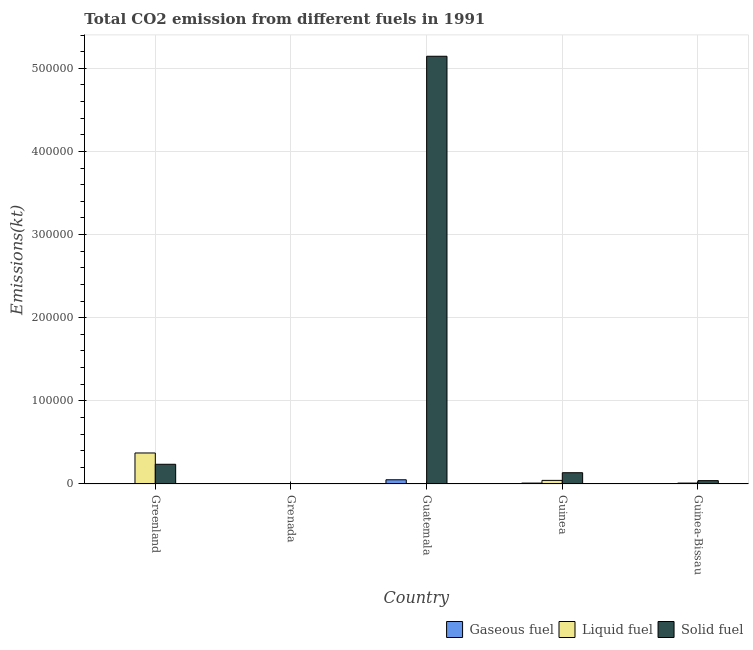How many different coloured bars are there?
Provide a short and direct response. 3. How many bars are there on the 2nd tick from the right?
Provide a succinct answer. 3. What is the label of the 3rd group of bars from the left?
Offer a terse response. Guatemala. In how many cases, is the number of bars for a given country not equal to the number of legend labels?
Offer a very short reply. 0. What is the amount of co2 emissions from gaseous fuel in Guinea?
Offer a terse response. 1074.43. Across all countries, what is the maximum amount of co2 emissions from gaseous fuel?
Offer a terse response. 5053.13. Across all countries, what is the minimum amount of co2 emissions from solid fuel?
Keep it short and to the point. 245.69. In which country was the amount of co2 emissions from liquid fuel maximum?
Offer a terse response. Greenland. In which country was the amount of co2 emissions from gaseous fuel minimum?
Make the answer very short. Grenada. What is the total amount of co2 emissions from solid fuel in the graph?
Give a very brief answer. 5.56e+05. What is the difference between the amount of co2 emissions from gaseous fuel in Greenland and that in Grenada?
Your answer should be very brief. 436.37. What is the difference between the amount of co2 emissions from gaseous fuel in Guinea-Bissau and the amount of co2 emissions from liquid fuel in Guinea?
Make the answer very short. -4059.37. What is the average amount of co2 emissions from gaseous fuel per country?
Make the answer very short. 1409.59. What is the difference between the amount of co2 emissions from liquid fuel and amount of co2 emissions from solid fuel in Guinea?
Your answer should be very brief. -9215.17. In how many countries, is the amount of co2 emissions from liquid fuel greater than 520000 kt?
Offer a terse response. 0. What is the ratio of the amount of co2 emissions from gaseous fuel in Grenada to that in Guatemala?
Make the answer very short. 0.02. Is the difference between the amount of co2 emissions from liquid fuel in Grenada and Guinea-Bissau greater than the difference between the amount of co2 emissions from solid fuel in Grenada and Guinea-Bissau?
Your answer should be compact. Yes. What is the difference between the highest and the second highest amount of co2 emissions from gaseous fuel?
Your answer should be very brief. 3978.7. What is the difference between the highest and the lowest amount of co2 emissions from solid fuel?
Provide a succinct answer. 5.14e+05. In how many countries, is the amount of co2 emissions from gaseous fuel greater than the average amount of co2 emissions from gaseous fuel taken over all countries?
Give a very brief answer. 1. Is the sum of the amount of co2 emissions from liquid fuel in Grenada and Guinea-Bissau greater than the maximum amount of co2 emissions from gaseous fuel across all countries?
Provide a succinct answer. No. What does the 2nd bar from the left in Greenland represents?
Provide a short and direct response. Liquid fuel. What does the 3rd bar from the right in Greenland represents?
Offer a very short reply. Gaseous fuel. How many countries are there in the graph?
Keep it short and to the point. 5. Are the values on the major ticks of Y-axis written in scientific E-notation?
Ensure brevity in your answer.  No. Does the graph contain any zero values?
Provide a short and direct response. No. Does the graph contain grids?
Keep it short and to the point. Yes. What is the title of the graph?
Give a very brief answer. Total CO2 emission from different fuels in 1991. Does "Ores and metals" appear as one of the legend labels in the graph?
Your answer should be compact. No. What is the label or title of the X-axis?
Provide a succinct answer. Country. What is the label or title of the Y-axis?
Make the answer very short. Emissions(kt). What is the Emissions(kt) of Gaseous fuel in Greenland?
Your answer should be very brief. 550.05. What is the Emissions(kt) in Liquid fuel in Greenland?
Provide a succinct answer. 3.73e+04. What is the Emissions(kt) in Solid fuel in Greenland?
Your response must be concise. 2.37e+04. What is the Emissions(kt) of Gaseous fuel in Grenada?
Ensure brevity in your answer.  113.68. What is the Emissions(kt) in Liquid fuel in Grenada?
Ensure brevity in your answer.  550.05. What is the Emissions(kt) of Solid fuel in Grenada?
Give a very brief answer. 245.69. What is the Emissions(kt) of Gaseous fuel in Guatemala?
Make the answer very short. 5053.13. What is the Emissions(kt) in Liquid fuel in Guatemala?
Provide a short and direct response. 113.68. What is the Emissions(kt) of Solid fuel in Guatemala?
Provide a short and direct response. 5.14e+05. What is the Emissions(kt) in Gaseous fuel in Guinea?
Keep it short and to the point. 1074.43. What is the Emissions(kt) of Liquid fuel in Guinea?
Offer a very short reply. 4316.06. What is the Emissions(kt) in Solid fuel in Guinea?
Make the answer very short. 1.35e+04. What is the Emissions(kt) in Gaseous fuel in Guinea-Bissau?
Your answer should be very brief. 256.69. What is the Emissions(kt) in Liquid fuel in Guinea-Bissau?
Your response must be concise. 1074.43. What is the Emissions(kt) of Solid fuel in Guinea-Bissau?
Offer a very short reply. 4015.36. Across all countries, what is the maximum Emissions(kt) in Gaseous fuel?
Your response must be concise. 5053.13. Across all countries, what is the maximum Emissions(kt) in Liquid fuel?
Your answer should be very brief. 3.73e+04. Across all countries, what is the maximum Emissions(kt) in Solid fuel?
Keep it short and to the point. 5.14e+05. Across all countries, what is the minimum Emissions(kt) of Gaseous fuel?
Ensure brevity in your answer.  113.68. Across all countries, what is the minimum Emissions(kt) of Liquid fuel?
Your response must be concise. 113.68. Across all countries, what is the minimum Emissions(kt) in Solid fuel?
Your answer should be compact. 245.69. What is the total Emissions(kt) of Gaseous fuel in the graph?
Offer a very short reply. 7047.97. What is the total Emissions(kt) in Liquid fuel in the graph?
Provide a short and direct response. 4.33e+04. What is the total Emissions(kt) in Solid fuel in the graph?
Offer a very short reply. 5.56e+05. What is the difference between the Emissions(kt) in Gaseous fuel in Greenland and that in Grenada?
Your answer should be very brief. 436.37. What is the difference between the Emissions(kt) in Liquid fuel in Greenland and that in Grenada?
Offer a terse response. 3.67e+04. What is the difference between the Emissions(kt) of Solid fuel in Greenland and that in Grenada?
Provide a succinct answer. 2.35e+04. What is the difference between the Emissions(kt) of Gaseous fuel in Greenland and that in Guatemala?
Make the answer very short. -4503.08. What is the difference between the Emissions(kt) in Liquid fuel in Greenland and that in Guatemala?
Keep it short and to the point. 3.72e+04. What is the difference between the Emissions(kt) in Solid fuel in Greenland and that in Guatemala?
Your answer should be compact. -4.91e+05. What is the difference between the Emissions(kt) of Gaseous fuel in Greenland and that in Guinea?
Make the answer very short. -524.38. What is the difference between the Emissions(kt) in Liquid fuel in Greenland and that in Guinea?
Offer a very short reply. 3.30e+04. What is the difference between the Emissions(kt) in Solid fuel in Greenland and that in Guinea?
Your response must be concise. 1.02e+04. What is the difference between the Emissions(kt) of Gaseous fuel in Greenland and that in Guinea-Bissau?
Provide a short and direct response. 293.36. What is the difference between the Emissions(kt) of Liquid fuel in Greenland and that in Guinea-Bissau?
Give a very brief answer. 3.62e+04. What is the difference between the Emissions(kt) in Solid fuel in Greenland and that in Guinea-Bissau?
Your response must be concise. 1.97e+04. What is the difference between the Emissions(kt) in Gaseous fuel in Grenada and that in Guatemala?
Provide a short and direct response. -4939.45. What is the difference between the Emissions(kt) of Liquid fuel in Grenada and that in Guatemala?
Offer a very short reply. 436.37. What is the difference between the Emissions(kt) of Solid fuel in Grenada and that in Guatemala?
Offer a terse response. -5.14e+05. What is the difference between the Emissions(kt) in Gaseous fuel in Grenada and that in Guinea?
Offer a very short reply. -960.75. What is the difference between the Emissions(kt) in Liquid fuel in Grenada and that in Guinea?
Make the answer very short. -3766.01. What is the difference between the Emissions(kt) of Solid fuel in Grenada and that in Guinea?
Provide a succinct answer. -1.33e+04. What is the difference between the Emissions(kt) in Gaseous fuel in Grenada and that in Guinea-Bissau?
Provide a short and direct response. -143.01. What is the difference between the Emissions(kt) in Liquid fuel in Grenada and that in Guinea-Bissau?
Your answer should be compact. -524.38. What is the difference between the Emissions(kt) in Solid fuel in Grenada and that in Guinea-Bissau?
Give a very brief answer. -3769.68. What is the difference between the Emissions(kt) in Gaseous fuel in Guatemala and that in Guinea?
Offer a very short reply. 3978.7. What is the difference between the Emissions(kt) of Liquid fuel in Guatemala and that in Guinea?
Provide a short and direct response. -4202.38. What is the difference between the Emissions(kt) in Solid fuel in Guatemala and that in Guinea?
Offer a very short reply. 5.01e+05. What is the difference between the Emissions(kt) in Gaseous fuel in Guatemala and that in Guinea-Bissau?
Offer a very short reply. 4796.44. What is the difference between the Emissions(kt) in Liquid fuel in Guatemala and that in Guinea-Bissau?
Provide a succinct answer. -960.75. What is the difference between the Emissions(kt) of Solid fuel in Guatemala and that in Guinea-Bissau?
Your answer should be compact. 5.10e+05. What is the difference between the Emissions(kt) in Gaseous fuel in Guinea and that in Guinea-Bissau?
Ensure brevity in your answer.  817.74. What is the difference between the Emissions(kt) in Liquid fuel in Guinea and that in Guinea-Bissau?
Offer a very short reply. 3241.63. What is the difference between the Emissions(kt) of Solid fuel in Guinea and that in Guinea-Bissau?
Your answer should be compact. 9515.86. What is the difference between the Emissions(kt) in Gaseous fuel in Greenland and the Emissions(kt) in Liquid fuel in Grenada?
Make the answer very short. 0. What is the difference between the Emissions(kt) in Gaseous fuel in Greenland and the Emissions(kt) in Solid fuel in Grenada?
Make the answer very short. 304.36. What is the difference between the Emissions(kt) in Liquid fuel in Greenland and the Emissions(kt) in Solid fuel in Grenada?
Offer a terse response. 3.70e+04. What is the difference between the Emissions(kt) in Gaseous fuel in Greenland and the Emissions(kt) in Liquid fuel in Guatemala?
Your answer should be very brief. 436.37. What is the difference between the Emissions(kt) of Gaseous fuel in Greenland and the Emissions(kt) of Solid fuel in Guatemala?
Make the answer very short. -5.14e+05. What is the difference between the Emissions(kt) in Liquid fuel in Greenland and the Emissions(kt) in Solid fuel in Guatemala?
Keep it short and to the point. -4.77e+05. What is the difference between the Emissions(kt) of Gaseous fuel in Greenland and the Emissions(kt) of Liquid fuel in Guinea?
Provide a succinct answer. -3766.01. What is the difference between the Emissions(kt) of Gaseous fuel in Greenland and the Emissions(kt) of Solid fuel in Guinea?
Make the answer very short. -1.30e+04. What is the difference between the Emissions(kt) of Liquid fuel in Greenland and the Emissions(kt) of Solid fuel in Guinea?
Offer a terse response. 2.38e+04. What is the difference between the Emissions(kt) in Gaseous fuel in Greenland and the Emissions(kt) in Liquid fuel in Guinea-Bissau?
Your answer should be very brief. -524.38. What is the difference between the Emissions(kt) in Gaseous fuel in Greenland and the Emissions(kt) in Solid fuel in Guinea-Bissau?
Provide a succinct answer. -3465.32. What is the difference between the Emissions(kt) in Liquid fuel in Greenland and the Emissions(kt) in Solid fuel in Guinea-Bissau?
Your response must be concise. 3.33e+04. What is the difference between the Emissions(kt) of Gaseous fuel in Grenada and the Emissions(kt) of Solid fuel in Guatemala?
Ensure brevity in your answer.  -5.14e+05. What is the difference between the Emissions(kt) in Liquid fuel in Grenada and the Emissions(kt) in Solid fuel in Guatemala?
Ensure brevity in your answer.  -5.14e+05. What is the difference between the Emissions(kt) in Gaseous fuel in Grenada and the Emissions(kt) in Liquid fuel in Guinea?
Provide a short and direct response. -4202.38. What is the difference between the Emissions(kt) of Gaseous fuel in Grenada and the Emissions(kt) of Solid fuel in Guinea?
Your answer should be very brief. -1.34e+04. What is the difference between the Emissions(kt) in Liquid fuel in Grenada and the Emissions(kt) in Solid fuel in Guinea?
Give a very brief answer. -1.30e+04. What is the difference between the Emissions(kt) of Gaseous fuel in Grenada and the Emissions(kt) of Liquid fuel in Guinea-Bissau?
Your response must be concise. -960.75. What is the difference between the Emissions(kt) in Gaseous fuel in Grenada and the Emissions(kt) in Solid fuel in Guinea-Bissau?
Your response must be concise. -3901.69. What is the difference between the Emissions(kt) in Liquid fuel in Grenada and the Emissions(kt) in Solid fuel in Guinea-Bissau?
Keep it short and to the point. -3465.32. What is the difference between the Emissions(kt) in Gaseous fuel in Guatemala and the Emissions(kt) in Liquid fuel in Guinea?
Your answer should be very brief. 737.07. What is the difference between the Emissions(kt) of Gaseous fuel in Guatemala and the Emissions(kt) of Solid fuel in Guinea?
Give a very brief answer. -8478.1. What is the difference between the Emissions(kt) of Liquid fuel in Guatemala and the Emissions(kt) of Solid fuel in Guinea?
Your response must be concise. -1.34e+04. What is the difference between the Emissions(kt) of Gaseous fuel in Guatemala and the Emissions(kt) of Liquid fuel in Guinea-Bissau?
Provide a short and direct response. 3978.7. What is the difference between the Emissions(kt) in Gaseous fuel in Guatemala and the Emissions(kt) in Solid fuel in Guinea-Bissau?
Your answer should be very brief. 1037.76. What is the difference between the Emissions(kt) in Liquid fuel in Guatemala and the Emissions(kt) in Solid fuel in Guinea-Bissau?
Offer a terse response. -3901.69. What is the difference between the Emissions(kt) of Gaseous fuel in Guinea and the Emissions(kt) of Solid fuel in Guinea-Bissau?
Your response must be concise. -2940.93. What is the difference between the Emissions(kt) of Liquid fuel in Guinea and the Emissions(kt) of Solid fuel in Guinea-Bissau?
Make the answer very short. 300.69. What is the average Emissions(kt) in Gaseous fuel per country?
Provide a succinct answer. 1409.59. What is the average Emissions(kt) in Liquid fuel per country?
Make the answer very short. 8668.05. What is the average Emissions(kt) in Solid fuel per country?
Provide a succinct answer. 1.11e+05. What is the difference between the Emissions(kt) of Gaseous fuel and Emissions(kt) of Liquid fuel in Greenland?
Ensure brevity in your answer.  -3.67e+04. What is the difference between the Emissions(kt) in Gaseous fuel and Emissions(kt) in Solid fuel in Greenland?
Give a very brief answer. -2.31e+04. What is the difference between the Emissions(kt) of Liquid fuel and Emissions(kt) of Solid fuel in Greenland?
Your answer should be compact. 1.36e+04. What is the difference between the Emissions(kt) in Gaseous fuel and Emissions(kt) in Liquid fuel in Grenada?
Offer a very short reply. -436.37. What is the difference between the Emissions(kt) in Gaseous fuel and Emissions(kt) in Solid fuel in Grenada?
Offer a very short reply. -132.01. What is the difference between the Emissions(kt) in Liquid fuel and Emissions(kt) in Solid fuel in Grenada?
Make the answer very short. 304.36. What is the difference between the Emissions(kt) in Gaseous fuel and Emissions(kt) in Liquid fuel in Guatemala?
Provide a short and direct response. 4939.45. What is the difference between the Emissions(kt) of Gaseous fuel and Emissions(kt) of Solid fuel in Guatemala?
Ensure brevity in your answer.  -5.09e+05. What is the difference between the Emissions(kt) in Liquid fuel and Emissions(kt) in Solid fuel in Guatemala?
Offer a very short reply. -5.14e+05. What is the difference between the Emissions(kt) of Gaseous fuel and Emissions(kt) of Liquid fuel in Guinea?
Your response must be concise. -3241.63. What is the difference between the Emissions(kt) of Gaseous fuel and Emissions(kt) of Solid fuel in Guinea?
Give a very brief answer. -1.25e+04. What is the difference between the Emissions(kt) of Liquid fuel and Emissions(kt) of Solid fuel in Guinea?
Make the answer very short. -9215.17. What is the difference between the Emissions(kt) of Gaseous fuel and Emissions(kt) of Liquid fuel in Guinea-Bissau?
Make the answer very short. -817.74. What is the difference between the Emissions(kt) of Gaseous fuel and Emissions(kt) of Solid fuel in Guinea-Bissau?
Keep it short and to the point. -3758.68. What is the difference between the Emissions(kt) of Liquid fuel and Emissions(kt) of Solid fuel in Guinea-Bissau?
Offer a terse response. -2940.93. What is the ratio of the Emissions(kt) in Gaseous fuel in Greenland to that in Grenada?
Provide a succinct answer. 4.84. What is the ratio of the Emissions(kt) in Liquid fuel in Greenland to that in Grenada?
Your answer should be very brief. 67.79. What is the ratio of the Emissions(kt) in Solid fuel in Greenland to that in Grenada?
Provide a succinct answer. 96.45. What is the ratio of the Emissions(kt) in Gaseous fuel in Greenland to that in Guatemala?
Provide a short and direct response. 0.11. What is the ratio of the Emissions(kt) in Liquid fuel in Greenland to that in Guatemala?
Your answer should be very brief. 328. What is the ratio of the Emissions(kt) in Solid fuel in Greenland to that in Guatemala?
Offer a terse response. 0.05. What is the ratio of the Emissions(kt) of Gaseous fuel in Greenland to that in Guinea?
Provide a succinct answer. 0.51. What is the ratio of the Emissions(kt) of Liquid fuel in Greenland to that in Guinea?
Ensure brevity in your answer.  8.64. What is the ratio of the Emissions(kt) of Solid fuel in Greenland to that in Guinea?
Offer a very short reply. 1.75. What is the ratio of the Emissions(kt) of Gaseous fuel in Greenland to that in Guinea-Bissau?
Offer a very short reply. 2.14. What is the ratio of the Emissions(kt) in Liquid fuel in Greenland to that in Guinea-Bissau?
Your answer should be very brief. 34.7. What is the ratio of the Emissions(kt) in Solid fuel in Greenland to that in Guinea-Bissau?
Give a very brief answer. 5.9. What is the ratio of the Emissions(kt) in Gaseous fuel in Grenada to that in Guatemala?
Provide a succinct answer. 0.02. What is the ratio of the Emissions(kt) in Liquid fuel in Grenada to that in Guatemala?
Ensure brevity in your answer.  4.84. What is the ratio of the Emissions(kt) in Gaseous fuel in Grenada to that in Guinea?
Offer a very short reply. 0.11. What is the ratio of the Emissions(kt) in Liquid fuel in Grenada to that in Guinea?
Make the answer very short. 0.13. What is the ratio of the Emissions(kt) in Solid fuel in Grenada to that in Guinea?
Ensure brevity in your answer.  0.02. What is the ratio of the Emissions(kt) of Gaseous fuel in Grenada to that in Guinea-Bissau?
Keep it short and to the point. 0.44. What is the ratio of the Emissions(kt) of Liquid fuel in Grenada to that in Guinea-Bissau?
Your answer should be compact. 0.51. What is the ratio of the Emissions(kt) of Solid fuel in Grenada to that in Guinea-Bissau?
Your answer should be compact. 0.06. What is the ratio of the Emissions(kt) in Gaseous fuel in Guatemala to that in Guinea?
Provide a short and direct response. 4.7. What is the ratio of the Emissions(kt) in Liquid fuel in Guatemala to that in Guinea?
Give a very brief answer. 0.03. What is the ratio of the Emissions(kt) in Solid fuel in Guatemala to that in Guinea?
Provide a short and direct response. 38.02. What is the ratio of the Emissions(kt) of Gaseous fuel in Guatemala to that in Guinea-Bissau?
Ensure brevity in your answer.  19.69. What is the ratio of the Emissions(kt) in Liquid fuel in Guatemala to that in Guinea-Bissau?
Offer a very short reply. 0.11. What is the ratio of the Emissions(kt) in Solid fuel in Guatemala to that in Guinea-Bissau?
Provide a short and direct response. 128.12. What is the ratio of the Emissions(kt) of Gaseous fuel in Guinea to that in Guinea-Bissau?
Your response must be concise. 4.19. What is the ratio of the Emissions(kt) of Liquid fuel in Guinea to that in Guinea-Bissau?
Offer a very short reply. 4.02. What is the ratio of the Emissions(kt) of Solid fuel in Guinea to that in Guinea-Bissau?
Your answer should be compact. 3.37. What is the difference between the highest and the second highest Emissions(kt) in Gaseous fuel?
Your answer should be very brief. 3978.7. What is the difference between the highest and the second highest Emissions(kt) in Liquid fuel?
Ensure brevity in your answer.  3.30e+04. What is the difference between the highest and the second highest Emissions(kt) of Solid fuel?
Make the answer very short. 4.91e+05. What is the difference between the highest and the lowest Emissions(kt) in Gaseous fuel?
Your response must be concise. 4939.45. What is the difference between the highest and the lowest Emissions(kt) of Liquid fuel?
Give a very brief answer. 3.72e+04. What is the difference between the highest and the lowest Emissions(kt) of Solid fuel?
Provide a succinct answer. 5.14e+05. 